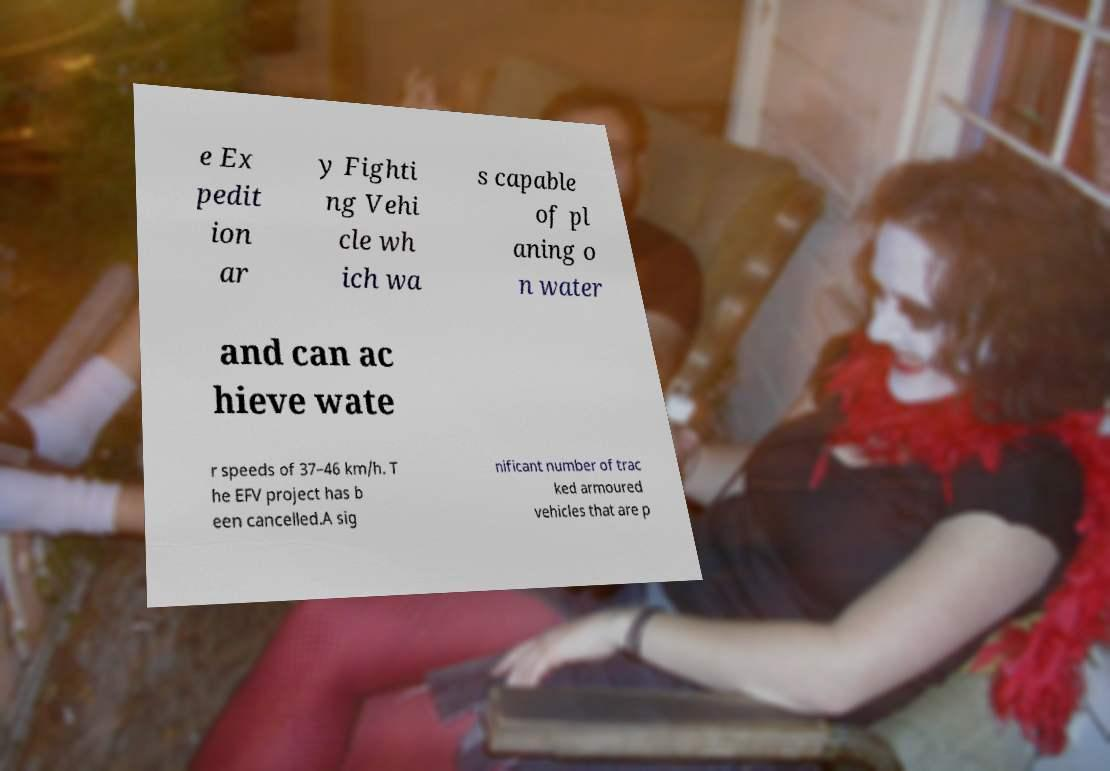I need the written content from this picture converted into text. Can you do that? e Ex pedit ion ar y Fighti ng Vehi cle wh ich wa s capable of pl aning o n water and can ac hieve wate r speeds of 37–46 km/h. T he EFV project has b een cancelled.A sig nificant number of trac ked armoured vehicles that are p 